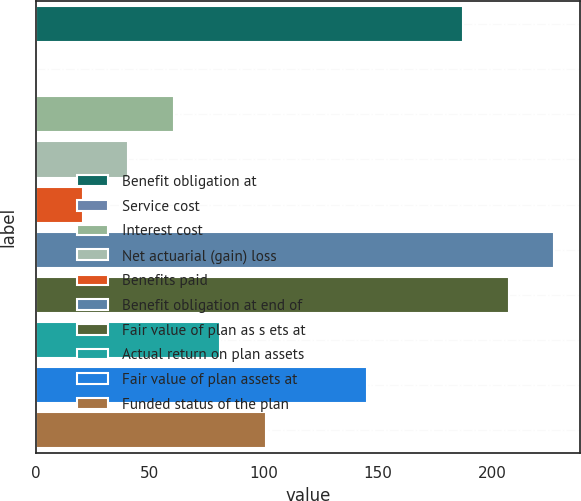<chart> <loc_0><loc_0><loc_500><loc_500><bar_chart><fcel>Benefit obligation at<fcel>Service cost<fcel>Interest cost<fcel>Net actuarial (gain) loss<fcel>Benefits paid<fcel>Benefit obligation at end of<fcel>Fair value of plan as s ets at<fcel>Actual return on plan assets<fcel>Fair value of plan assets at<fcel>Funded status of the plan<nl><fcel>187.3<fcel>0.4<fcel>60.61<fcel>40.54<fcel>20.47<fcel>227.44<fcel>207.37<fcel>80.68<fcel>145<fcel>100.75<nl></chart> 